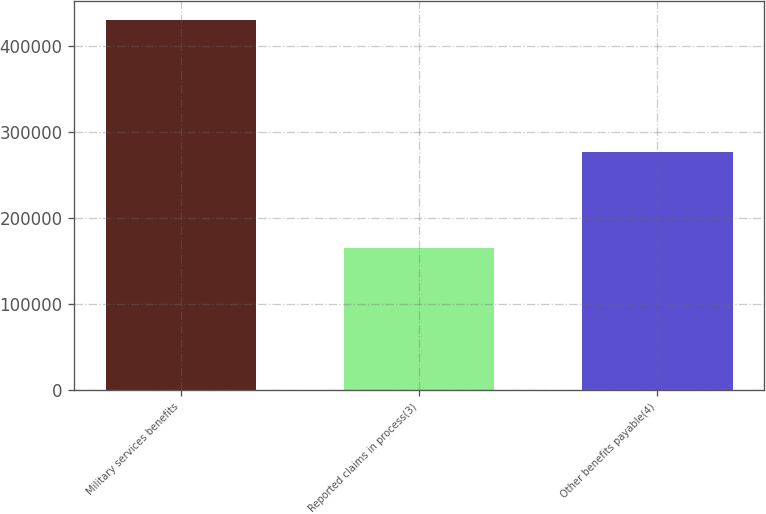<chart> <loc_0><loc_0><loc_500><loc_500><bar_chart><fcel>Military services benefits<fcel>Reported claims in process(3)<fcel>Other benefits payable(4)<nl><fcel>430674<fcel>165254<fcel>276422<nl></chart> 